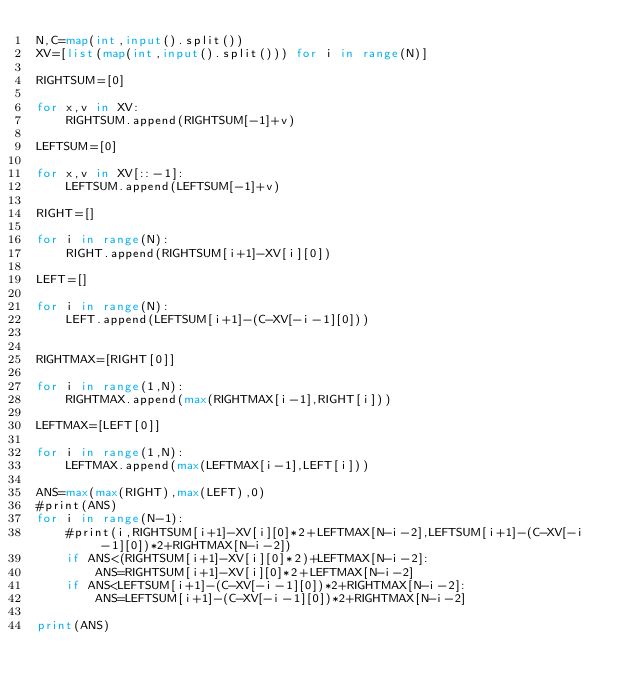Convert code to text. <code><loc_0><loc_0><loc_500><loc_500><_Python_>N,C=map(int,input().split())
XV=[list(map(int,input().split())) for i in range(N)]

RIGHTSUM=[0]

for x,v in XV:
    RIGHTSUM.append(RIGHTSUM[-1]+v)

LEFTSUM=[0]

for x,v in XV[::-1]:
    LEFTSUM.append(LEFTSUM[-1]+v)

RIGHT=[]

for i in range(N):
    RIGHT.append(RIGHTSUM[i+1]-XV[i][0])

LEFT=[]

for i in range(N):
    LEFT.append(LEFTSUM[i+1]-(C-XV[-i-1][0]))


RIGHTMAX=[RIGHT[0]]

for i in range(1,N):
    RIGHTMAX.append(max(RIGHTMAX[i-1],RIGHT[i]))

LEFTMAX=[LEFT[0]]

for i in range(1,N):
    LEFTMAX.append(max(LEFTMAX[i-1],LEFT[i]))

ANS=max(max(RIGHT),max(LEFT),0)
#print(ANS)
for i in range(N-1):
    #print(i,RIGHTSUM[i+1]-XV[i][0]*2+LEFTMAX[N-i-2],LEFTSUM[i+1]-(C-XV[-i-1][0])*2+RIGHTMAX[N-i-2])
    if ANS<(RIGHTSUM[i+1]-XV[i][0]*2)+LEFTMAX[N-i-2]:
        ANS=RIGHTSUM[i+1]-XV[i][0]*2+LEFTMAX[N-i-2]
    if ANS<LEFTSUM[i+1]-(C-XV[-i-1][0])*2+RIGHTMAX[N-i-2]:
        ANS=LEFTSUM[i+1]-(C-XV[-i-1][0])*2+RIGHTMAX[N-i-2]

print(ANS)
    
</code> 